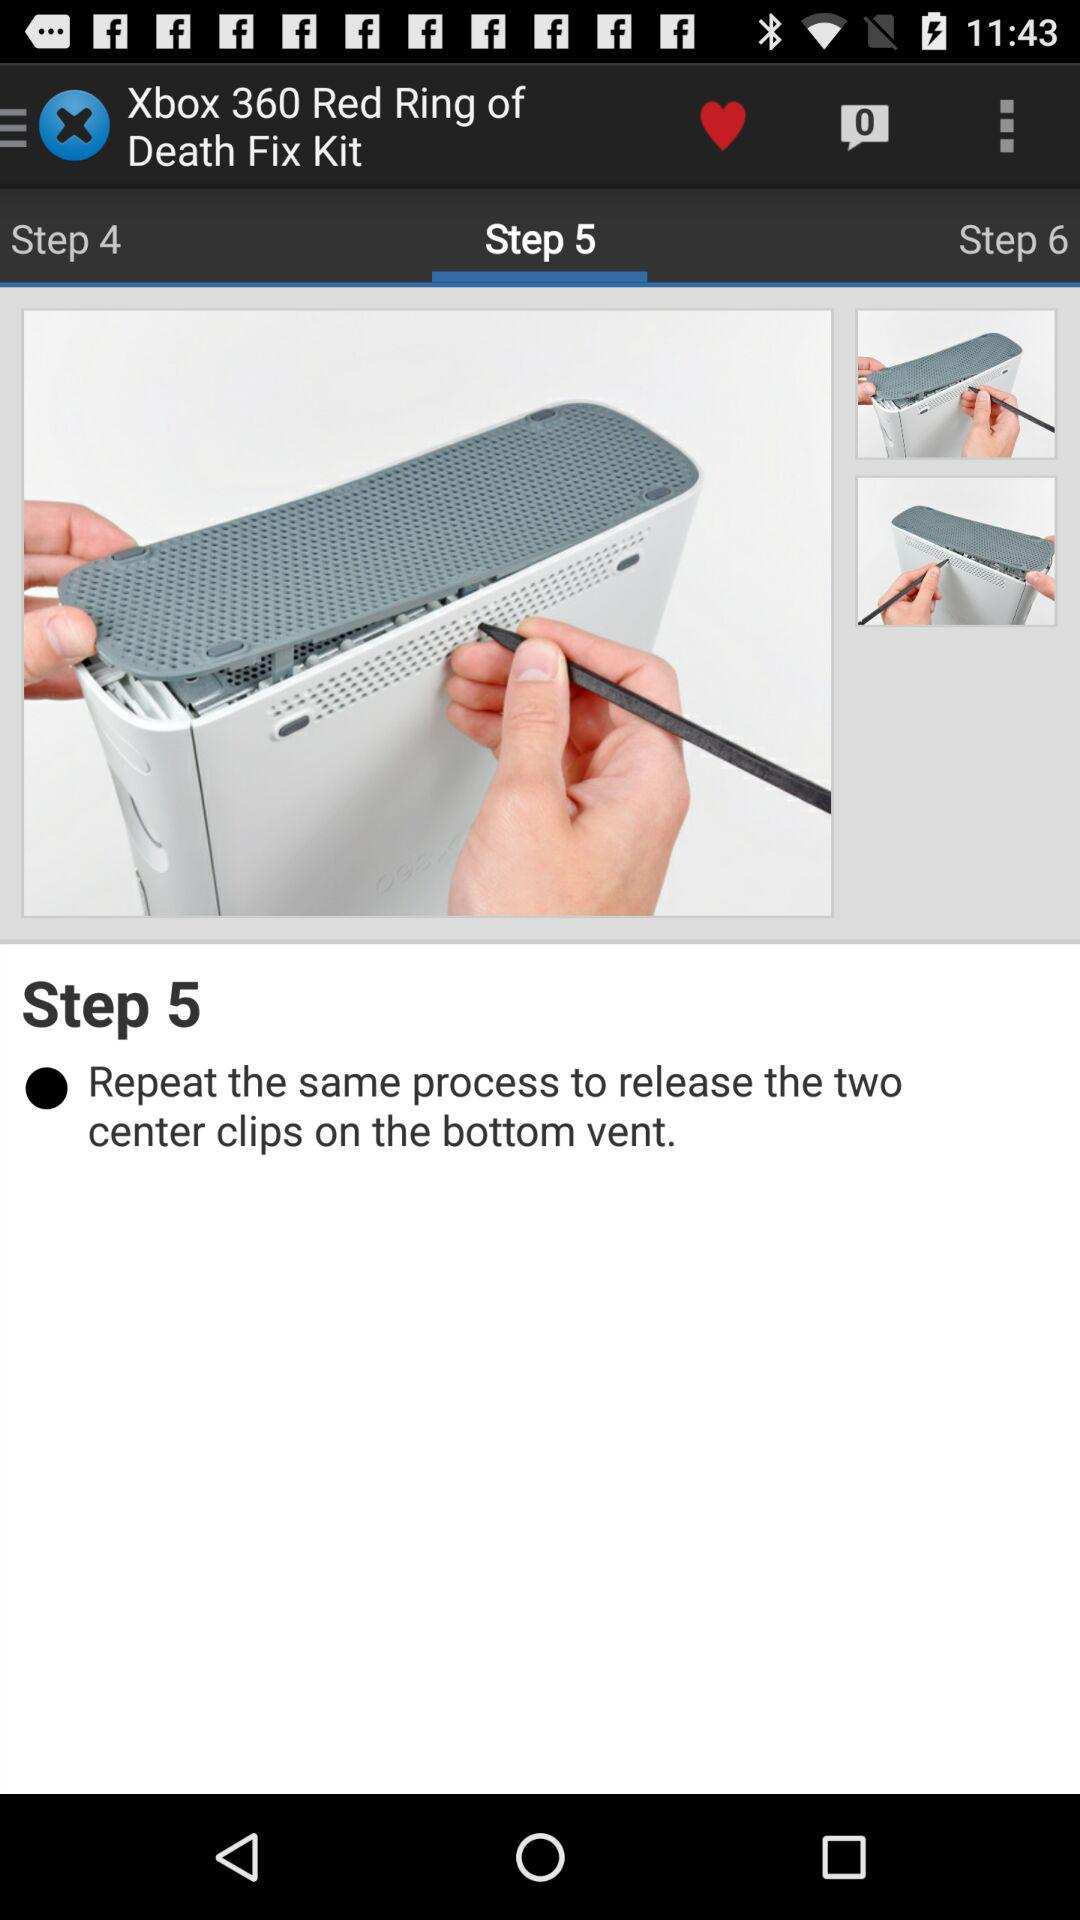How many steps are there in the process of fixing the Xbox 360 Red Ring of Death?
Answer the question using a single word or phrase. 6 